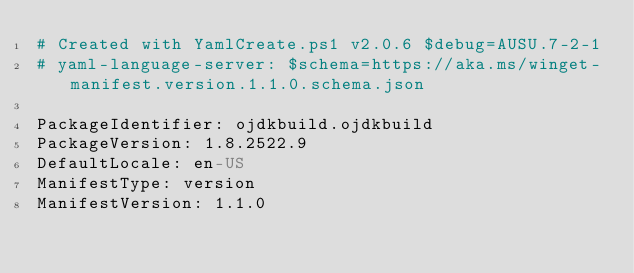<code> <loc_0><loc_0><loc_500><loc_500><_YAML_># Created with YamlCreate.ps1 v2.0.6 $debug=AUSU.7-2-1
# yaml-language-server: $schema=https://aka.ms/winget-manifest.version.1.1.0.schema.json

PackageIdentifier: ojdkbuild.ojdkbuild
PackageVersion: 1.8.2522.9
DefaultLocale: en-US
ManifestType: version
ManifestVersion: 1.1.0
</code> 